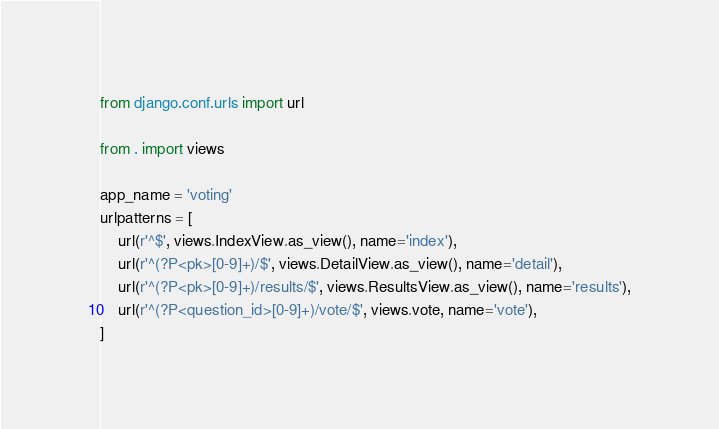Convert code to text. <code><loc_0><loc_0><loc_500><loc_500><_Python_>from django.conf.urls import url

from . import views

app_name = 'voting'
urlpatterns = [
    url(r'^$', views.IndexView.as_view(), name='index'),
    url(r'^(?P<pk>[0-9]+)/$', views.DetailView.as_view(), name='detail'),
    url(r'^(?P<pk>[0-9]+)/results/$', views.ResultsView.as_view(), name='results'),
    url(r'^(?P<question_id>[0-9]+)/vote/$', views.vote, name='vote'),
]
</code> 